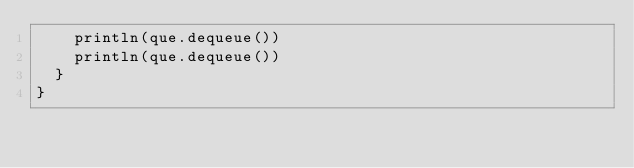<code> <loc_0><loc_0><loc_500><loc_500><_Scala_>    println(que.dequeue())
    println(que.dequeue())
  }
}
</code> 